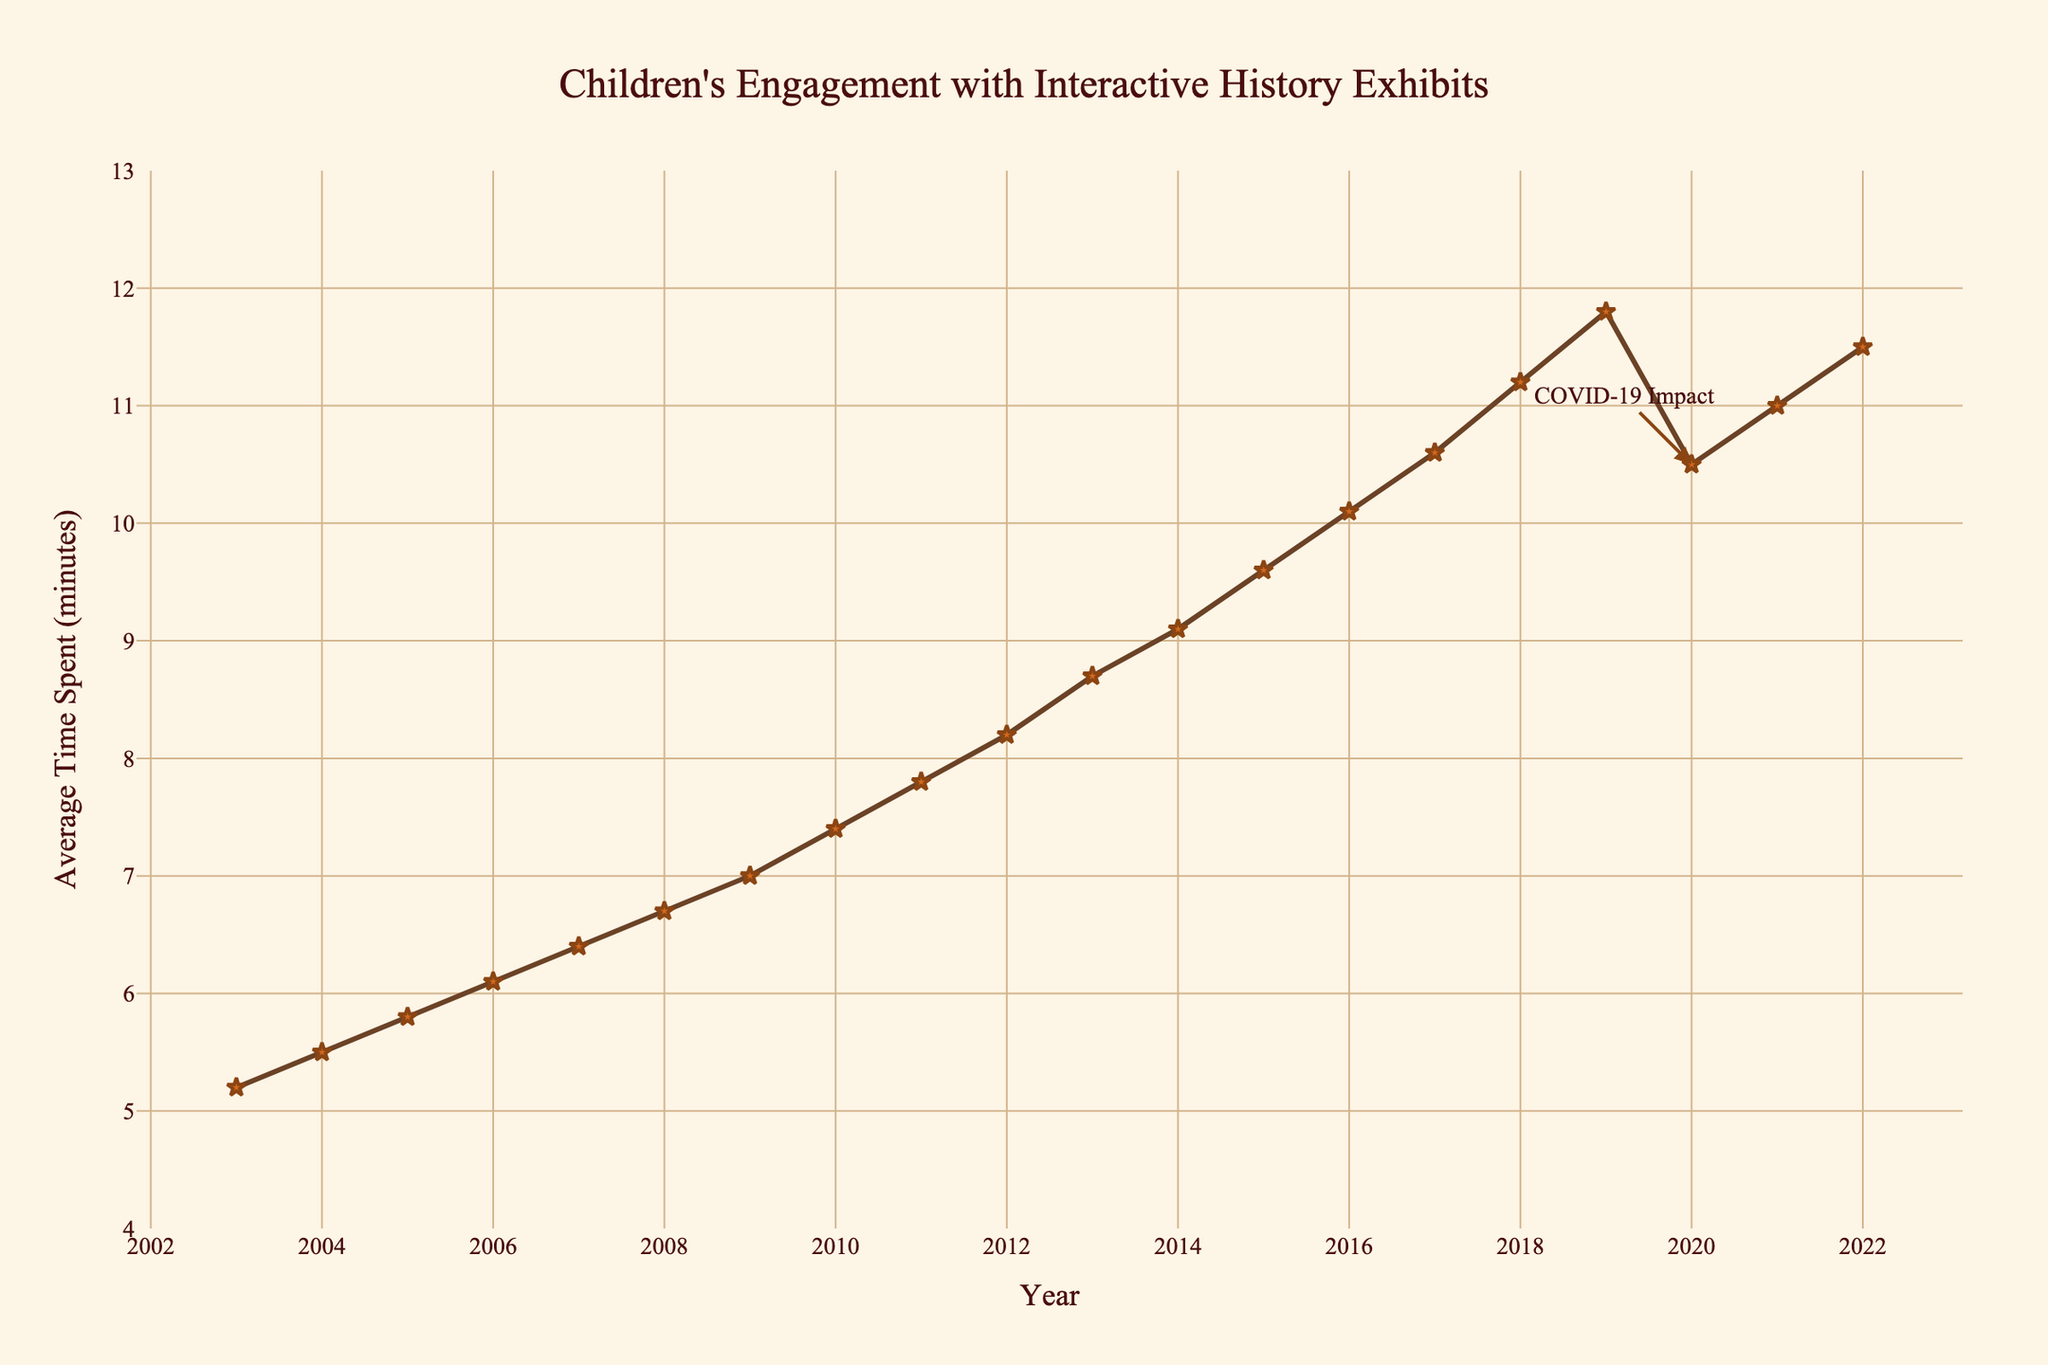What was the average time spent per exhibit in 2003? Look at the data point for 2003 on the x-axis and check its corresponding y-axis value.
Answer: 5.2 minutes How much did the average time spent per exhibit increase from 2003 to 2022? Find the difference between the values for 2022 and 2003. 11.5 - 5.2 = 6.3 minutes
Answer: 6.3 minutes What year saw the most significant drop in the average time spent per exhibit? Identify the steepest decline on the line chart, which occurs between 2019 and 2020.
Answer: 2020 What is the general trend of children's engagement with interactive history exhibits over the last 20 years? Observe the overall slope of the line from 2003 to 2022, which shows an upward trend.
Answer: Increasing How did the COVID-19 pandemic impact children's engagement in 2020 compared to 2019? Compare the 2019 value with the 2020 value; 11.8 (2019) - 10.5 (2020) = 1.3 minutes decrease.
Answer: Decreased by 1.3 minutes Which years showed a consistent increase in engagement without any drop or plateau? Look for periods where the line continuously rises without falling or flattening: 2003 to 2019.
Answer: 2003 to 2019 What was the average time spent per exhibit in 2010 and how does it compare to 2006? Identify the y-values for both 2010 (7.4) and 2006 (6.1) and compare. 7.4 - 6.1 = 1.3 minutes difference.
Answer: 1.3 minutes increase How did the engagement trend change after 2020? Observe the slope of the line from 2020 to 2022, which shows an increasing trend after the drop in 2020.
Answer: Increasing Calculate the average engagement time for the decade 2010-2019. Sum the values for each year from 2010 to 2019 and divide by 10. (7.4+7.8+8.2+8.7+9.1+9.6+10.1+10.6+11.2+11.8)/10 = 9.35 minutes.
Answer: 9.35 minutes What visual element indicates the COVID-19 impact on the chart? Look for annotations and visually distinct markers; there is an annotation labeled "COVID-19 Impact" at 2020.
Answer: Annotation pointing to 2020 value 